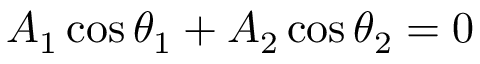<formula> <loc_0><loc_0><loc_500><loc_500>A _ { 1 } \cos \theta _ { 1 } + A _ { 2 } \cos \theta _ { 2 } = 0</formula> 